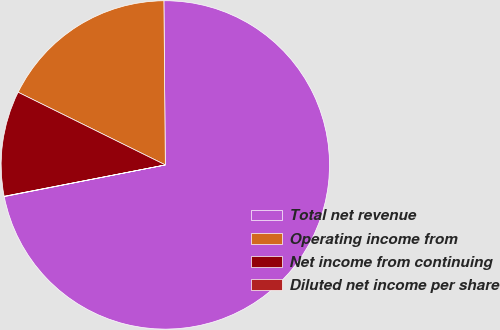<chart> <loc_0><loc_0><loc_500><loc_500><pie_chart><fcel>Total net revenue<fcel>Operating income from<fcel>Net income from continuing<fcel>Diluted net income per share<nl><fcel>72.05%<fcel>17.56%<fcel>10.36%<fcel>0.03%<nl></chart> 